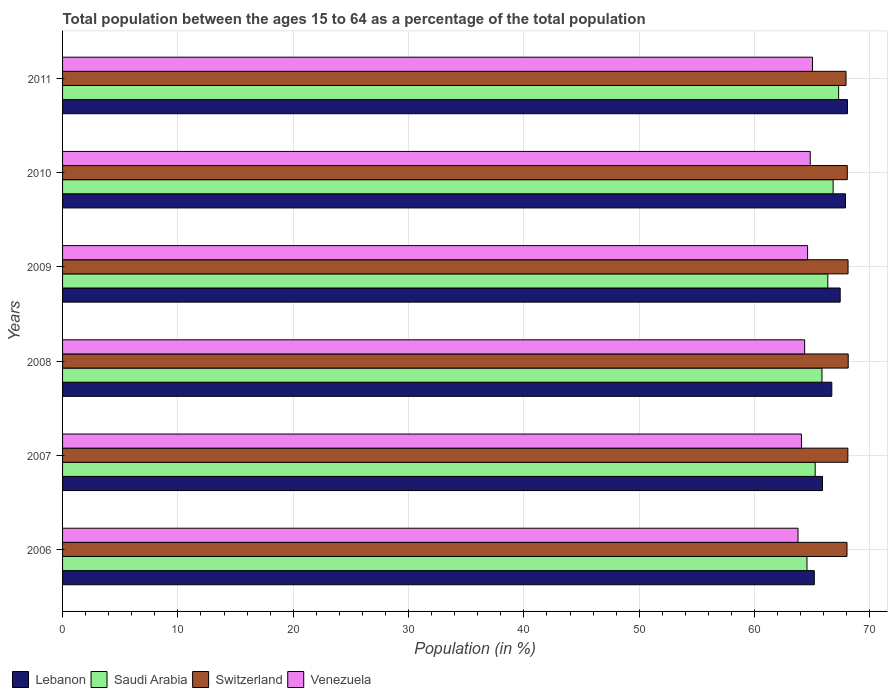How many groups of bars are there?
Keep it short and to the point. 6. How many bars are there on the 3rd tick from the bottom?
Ensure brevity in your answer.  4. In how many cases, is the number of bars for a given year not equal to the number of legend labels?
Ensure brevity in your answer.  0. What is the percentage of the population ages 15 to 64 in Lebanon in 2009?
Your answer should be very brief. 67.42. Across all years, what is the maximum percentage of the population ages 15 to 64 in Venezuela?
Your answer should be very brief. 65.02. Across all years, what is the minimum percentage of the population ages 15 to 64 in Saudi Arabia?
Your response must be concise. 64.54. What is the total percentage of the population ages 15 to 64 in Lebanon in the graph?
Ensure brevity in your answer.  401.12. What is the difference between the percentage of the population ages 15 to 64 in Lebanon in 2008 and that in 2009?
Provide a short and direct response. -0.73. What is the difference between the percentage of the population ages 15 to 64 in Lebanon in 2009 and the percentage of the population ages 15 to 64 in Saudi Arabia in 2011?
Your answer should be very brief. 0.14. What is the average percentage of the population ages 15 to 64 in Switzerland per year?
Offer a terse response. 68.05. In the year 2006, what is the difference between the percentage of the population ages 15 to 64 in Switzerland and percentage of the population ages 15 to 64 in Venezuela?
Your answer should be very brief. 4.25. In how many years, is the percentage of the population ages 15 to 64 in Saudi Arabia greater than 18 ?
Keep it short and to the point. 6. What is the ratio of the percentage of the population ages 15 to 64 in Switzerland in 2006 to that in 2010?
Offer a terse response. 1. Is the percentage of the population ages 15 to 64 in Lebanon in 2009 less than that in 2010?
Your answer should be very brief. Yes. What is the difference between the highest and the second highest percentage of the population ages 15 to 64 in Venezuela?
Keep it short and to the point. 0.2. What is the difference between the highest and the lowest percentage of the population ages 15 to 64 in Venezuela?
Make the answer very short. 1.25. In how many years, is the percentage of the population ages 15 to 64 in Venezuela greater than the average percentage of the population ages 15 to 64 in Venezuela taken over all years?
Your response must be concise. 3. Is it the case that in every year, the sum of the percentage of the population ages 15 to 64 in Switzerland and percentage of the population ages 15 to 64 in Saudi Arabia is greater than the sum of percentage of the population ages 15 to 64 in Venezuela and percentage of the population ages 15 to 64 in Lebanon?
Provide a short and direct response. Yes. What does the 2nd bar from the top in 2011 represents?
Your response must be concise. Switzerland. What does the 4th bar from the bottom in 2006 represents?
Your answer should be compact. Venezuela. Are all the bars in the graph horizontal?
Provide a succinct answer. Yes. How many years are there in the graph?
Offer a terse response. 6. Are the values on the major ticks of X-axis written in scientific E-notation?
Your answer should be compact. No. How many legend labels are there?
Offer a very short reply. 4. What is the title of the graph?
Your answer should be very brief. Total population between the ages 15 to 64 as a percentage of the total population. What is the label or title of the Y-axis?
Ensure brevity in your answer.  Years. What is the Population (in %) of Lebanon in 2006?
Keep it short and to the point. 65.18. What is the Population (in %) of Saudi Arabia in 2006?
Offer a very short reply. 64.54. What is the Population (in %) of Switzerland in 2006?
Provide a succinct answer. 68.01. What is the Population (in %) in Venezuela in 2006?
Ensure brevity in your answer.  63.77. What is the Population (in %) in Lebanon in 2007?
Provide a succinct answer. 65.89. What is the Population (in %) in Saudi Arabia in 2007?
Your answer should be very brief. 65.25. What is the Population (in %) in Switzerland in 2007?
Your answer should be very brief. 68.09. What is the Population (in %) of Venezuela in 2007?
Provide a short and direct response. 64.06. What is the Population (in %) of Lebanon in 2008?
Your response must be concise. 66.69. What is the Population (in %) of Saudi Arabia in 2008?
Ensure brevity in your answer.  65.84. What is the Population (in %) of Switzerland in 2008?
Make the answer very short. 68.12. What is the Population (in %) of Venezuela in 2008?
Offer a terse response. 64.34. What is the Population (in %) of Lebanon in 2009?
Provide a succinct answer. 67.42. What is the Population (in %) in Saudi Arabia in 2009?
Provide a succinct answer. 66.35. What is the Population (in %) in Switzerland in 2009?
Give a very brief answer. 68.1. What is the Population (in %) in Venezuela in 2009?
Give a very brief answer. 64.59. What is the Population (in %) of Lebanon in 2010?
Offer a very short reply. 67.88. What is the Population (in %) of Saudi Arabia in 2010?
Your answer should be very brief. 66.81. What is the Population (in %) of Switzerland in 2010?
Your answer should be very brief. 68.04. What is the Population (in %) of Venezuela in 2010?
Ensure brevity in your answer.  64.82. What is the Population (in %) in Lebanon in 2011?
Your answer should be very brief. 68.05. What is the Population (in %) in Saudi Arabia in 2011?
Your answer should be very brief. 67.29. What is the Population (in %) of Switzerland in 2011?
Provide a short and direct response. 67.93. What is the Population (in %) of Venezuela in 2011?
Offer a terse response. 65.02. Across all years, what is the maximum Population (in %) in Lebanon?
Ensure brevity in your answer.  68.05. Across all years, what is the maximum Population (in %) in Saudi Arabia?
Provide a short and direct response. 67.29. Across all years, what is the maximum Population (in %) of Switzerland?
Your response must be concise. 68.12. Across all years, what is the maximum Population (in %) in Venezuela?
Ensure brevity in your answer.  65.02. Across all years, what is the minimum Population (in %) in Lebanon?
Ensure brevity in your answer.  65.18. Across all years, what is the minimum Population (in %) of Saudi Arabia?
Make the answer very short. 64.54. Across all years, what is the minimum Population (in %) in Switzerland?
Offer a terse response. 67.93. Across all years, what is the minimum Population (in %) of Venezuela?
Keep it short and to the point. 63.77. What is the total Population (in %) in Lebanon in the graph?
Your answer should be very brief. 401.12. What is the total Population (in %) in Saudi Arabia in the graph?
Provide a succinct answer. 396.09. What is the total Population (in %) in Switzerland in the graph?
Your answer should be compact. 408.28. What is the total Population (in %) in Venezuela in the graph?
Offer a very short reply. 386.61. What is the difference between the Population (in %) in Lebanon in 2006 and that in 2007?
Your answer should be very brief. -0.71. What is the difference between the Population (in %) of Saudi Arabia in 2006 and that in 2007?
Give a very brief answer. -0.71. What is the difference between the Population (in %) of Switzerland in 2006 and that in 2007?
Provide a succinct answer. -0.07. What is the difference between the Population (in %) in Venezuela in 2006 and that in 2007?
Your answer should be very brief. -0.3. What is the difference between the Population (in %) of Lebanon in 2006 and that in 2008?
Provide a succinct answer. -1.52. What is the difference between the Population (in %) in Saudi Arabia in 2006 and that in 2008?
Offer a very short reply. -1.3. What is the difference between the Population (in %) in Switzerland in 2006 and that in 2008?
Keep it short and to the point. -0.1. What is the difference between the Population (in %) of Venezuela in 2006 and that in 2008?
Offer a terse response. -0.57. What is the difference between the Population (in %) of Lebanon in 2006 and that in 2009?
Offer a very short reply. -2.24. What is the difference between the Population (in %) of Saudi Arabia in 2006 and that in 2009?
Your response must be concise. -1.81. What is the difference between the Population (in %) in Switzerland in 2006 and that in 2009?
Your answer should be compact. -0.09. What is the difference between the Population (in %) of Venezuela in 2006 and that in 2009?
Your answer should be compact. -0.83. What is the difference between the Population (in %) of Lebanon in 2006 and that in 2010?
Keep it short and to the point. -2.7. What is the difference between the Population (in %) of Saudi Arabia in 2006 and that in 2010?
Offer a very short reply. -2.27. What is the difference between the Population (in %) of Switzerland in 2006 and that in 2010?
Provide a succinct answer. -0.03. What is the difference between the Population (in %) of Venezuela in 2006 and that in 2010?
Make the answer very short. -1.06. What is the difference between the Population (in %) in Lebanon in 2006 and that in 2011?
Ensure brevity in your answer.  -2.87. What is the difference between the Population (in %) in Saudi Arabia in 2006 and that in 2011?
Offer a very short reply. -2.74. What is the difference between the Population (in %) of Switzerland in 2006 and that in 2011?
Offer a very short reply. 0.08. What is the difference between the Population (in %) of Venezuela in 2006 and that in 2011?
Ensure brevity in your answer.  -1.25. What is the difference between the Population (in %) of Lebanon in 2007 and that in 2008?
Offer a very short reply. -0.81. What is the difference between the Population (in %) of Saudi Arabia in 2007 and that in 2008?
Your answer should be very brief. -0.59. What is the difference between the Population (in %) in Switzerland in 2007 and that in 2008?
Provide a succinct answer. -0.03. What is the difference between the Population (in %) in Venezuela in 2007 and that in 2008?
Your answer should be compact. -0.28. What is the difference between the Population (in %) of Lebanon in 2007 and that in 2009?
Your answer should be compact. -1.53. What is the difference between the Population (in %) of Saudi Arabia in 2007 and that in 2009?
Provide a short and direct response. -1.1. What is the difference between the Population (in %) of Switzerland in 2007 and that in 2009?
Offer a terse response. -0.02. What is the difference between the Population (in %) in Venezuela in 2007 and that in 2009?
Provide a short and direct response. -0.53. What is the difference between the Population (in %) in Lebanon in 2007 and that in 2010?
Keep it short and to the point. -1.99. What is the difference between the Population (in %) of Saudi Arabia in 2007 and that in 2010?
Keep it short and to the point. -1.56. What is the difference between the Population (in %) of Switzerland in 2007 and that in 2010?
Provide a short and direct response. 0.05. What is the difference between the Population (in %) of Venezuela in 2007 and that in 2010?
Provide a succinct answer. -0.76. What is the difference between the Population (in %) in Lebanon in 2007 and that in 2011?
Your answer should be very brief. -2.16. What is the difference between the Population (in %) of Saudi Arabia in 2007 and that in 2011?
Your answer should be compact. -2.03. What is the difference between the Population (in %) of Switzerland in 2007 and that in 2011?
Your response must be concise. 0.16. What is the difference between the Population (in %) in Venezuela in 2007 and that in 2011?
Make the answer very short. -0.96. What is the difference between the Population (in %) of Lebanon in 2008 and that in 2009?
Offer a very short reply. -0.73. What is the difference between the Population (in %) in Saudi Arabia in 2008 and that in 2009?
Your answer should be compact. -0.51. What is the difference between the Population (in %) in Switzerland in 2008 and that in 2009?
Your response must be concise. 0.01. What is the difference between the Population (in %) in Venezuela in 2008 and that in 2009?
Offer a very short reply. -0.25. What is the difference between the Population (in %) of Lebanon in 2008 and that in 2010?
Make the answer very short. -1.19. What is the difference between the Population (in %) in Saudi Arabia in 2008 and that in 2010?
Offer a very short reply. -0.97. What is the difference between the Population (in %) of Switzerland in 2008 and that in 2010?
Your response must be concise. 0.08. What is the difference between the Population (in %) in Venezuela in 2008 and that in 2010?
Your response must be concise. -0.48. What is the difference between the Population (in %) in Lebanon in 2008 and that in 2011?
Provide a short and direct response. -1.36. What is the difference between the Population (in %) in Saudi Arabia in 2008 and that in 2011?
Your answer should be compact. -1.44. What is the difference between the Population (in %) of Switzerland in 2008 and that in 2011?
Make the answer very short. 0.19. What is the difference between the Population (in %) of Venezuela in 2008 and that in 2011?
Give a very brief answer. -0.68. What is the difference between the Population (in %) of Lebanon in 2009 and that in 2010?
Make the answer very short. -0.46. What is the difference between the Population (in %) of Saudi Arabia in 2009 and that in 2010?
Make the answer very short. -0.46. What is the difference between the Population (in %) in Switzerland in 2009 and that in 2010?
Offer a terse response. 0.06. What is the difference between the Population (in %) in Venezuela in 2009 and that in 2010?
Your answer should be very brief. -0.23. What is the difference between the Population (in %) in Lebanon in 2009 and that in 2011?
Offer a terse response. -0.63. What is the difference between the Population (in %) in Saudi Arabia in 2009 and that in 2011?
Provide a short and direct response. -0.94. What is the difference between the Population (in %) in Switzerland in 2009 and that in 2011?
Your answer should be compact. 0.17. What is the difference between the Population (in %) in Venezuela in 2009 and that in 2011?
Ensure brevity in your answer.  -0.43. What is the difference between the Population (in %) of Lebanon in 2010 and that in 2011?
Your response must be concise. -0.17. What is the difference between the Population (in %) of Saudi Arabia in 2010 and that in 2011?
Provide a succinct answer. -0.47. What is the difference between the Population (in %) of Switzerland in 2010 and that in 2011?
Make the answer very short. 0.11. What is the difference between the Population (in %) in Venezuela in 2010 and that in 2011?
Offer a terse response. -0.2. What is the difference between the Population (in %) of Lebanon in 2006 and the Population (in %) of Saudi Arabia in 2007?
Offer a very short reply. -0.08. What is the difference between the Population (in %) of Lebanon in 2006 and the Population (in %) of Switzerland in 2007?
Your answer should be compact. -2.91. What is the difference between the Population (in %) of Lebanon in 2006 and the Population (in %) of Venezuela in 2007?
Give a very brief answer. 1.11. What is the difference between the Population (in %) of Saudi Arabia in 2006 and the Population (in %) of Switzerland in 2007?
Your answer should be very brief. -3.54. What is the difference between the Population (in %) in Saudi Arabia in 2006 and the Population (in %) in Venezuela in 2007?
Provide a succinct answer. 0.48. What is the difference between the Population (in %) in Switzerland in 2006 and the Population (in %) in Venezuela in 2007?
Your response must be concise. 3.95. What is the difference between the Population (in %) in Lebanon in 2006 and the Population (in %) in Saudi Arabia in 2008?
Ensure brevity in your answer.  -0.66. What is the difference between the Population (in %) of Lebanon in 2006 and the Population (in %) of Switzerland in 2008?
Provide a short and direct response. -2.94. What is the difference between the Population (in %) in Lebanon in 2006 and the Population (in %) in Venezuela in 2008?
Keep it short and to the point. 0.84. What is the difference between the Population (in %) of Saudi Arabia in 2006 and the Population (in %) of Switzerland in 2008?
Your answer should be very brief. -3.57. What is the difference between the Population (in %) in Saudi Arabia in 2006 and the Population (in %) in Venezuela in 2008?
Your response must be concise. 0.2. What is the difference between the Population (in %) of Switzerland in 2006 and the Population (in %) of Venezuela in 2008?
Your answer should be very brief. 3.67. What is the difference between the Population (in %) in Lebanon in 2006 and the Population (in %) in Saudi Arabia in 2009?
Offer a terse response. -1.17. What is the difference between the Population (in %) of Lebanon in 2006 and the Population (in %) of Switzerland in 2009?
Keep it short and to the point. -2.92. What is the difference between the Population (in %) of Lebanon in 2006 and the Population (in %) of Venezuela in 2009?
Give a very brief answer. 0.58. What is the difference between the Population (in %) in Saudi Arabia in 2006 and the Population (in %) in Switzerland in 2009?
Provide a short and direct response. -3.56. What is the difference between the Population (in %) of Saudi Arabia in 2006 and the Population (in %) of Venezuela in 2009?
Make the answer very short. -0.05. What is the difference between the Population (in %) of Switzerland in 2006 and the Population (in %) of Venezuela in 2009?
Your response must be concise. 3.42. What is the difference between the Population (in %) of Lebanon in 2006 and the Population (in %) of Saudi Arabia in 2010?
Your answer should be very brief. -1.63. What is the difference between the Population (in %) of Lebanon in 2006 and the Population (in %) of Switzerland in 2010?
Keep it short and to the point. -2.86. What is the difference between the Population (in %) in Lebanon in 2006 and the Population (in %) in Venezuela in 2010?
Provide a succinct answer. 0.35. What is the difference between the Population (in %) of Saudi Arabia in 2006 and the Population (in %) of Switzerland in 2010?
Give a very brief answer. -3.49. What is the difference between the Population (in %) in Saudi Arabia in 2006 and the Population (in %) in Venezuela in 2010?
Your answer should be very brief. -0.28. What is the difference between the Population (in %) in Switzerland in 2006 and the Population (in %) in Venezuela in 2010?
Your answer should be very brief. 3.19. What is the difference between the Population (in %) in Lebanon in 2006 and the Population (in %) in Saudi Arabia in 2011?
Offer a terse response. -2.11. What is the difference between the Population (in %) of Lebanon in 2006 and the Population (in %) of Switzerland in 2011?
Offer a very short reply. -2.75. What is the difference between the Population (in %) in Lebanon in 2006 and the Population (in %) in Venezuela in 2011?
Give a very brief answer. 0.16. What is the difference between the Population (in %) of Saudi Arabia in 2006 and the Population (in %) of Switzerland in 2011?
Give a very brief answer. -3.39. What is the difference between the Population (in %) in Saudi Arabia in 2006 and the Population (in %) in Venezuela in 2011?
Your response must be concise. -0.48. What is the difference between the Population (in %) in Switzerland in 2006 and the Population (in %) in Venezuela in 2011?
Provide a short and direct response. 2.99. What is the difference between the Population (in %) in Lebanon in 2007 and the Population (in %) in Saudi Arabia in 2008?
Your response must be concise. 0.05. What is the difference between the Population (in %) of Lebanon in 2007 and the Population (in %) of Switzerland in 2008?
Offer a terse response. -2.23. What is the difference between the Population (in %) of Lebanon in 2007 and the Population (in %) of Venezuela in 2008?
Provide a short and direct response. 1.55. What is the difference between the Population (in %) in Saudi Arabia in 2007 and the Population (in %) in Switzerland in 2008?
Ensure brevity in your answer.  -2.86. What is the difference between the Population (in %) of Saudi Arabia in 2007 and the Population (in %) of Venezuela in 2008?
Your answer should be very brief. 0.91. What is the difference between the Population (in %) in Switzerland in 2007 and the Population (in %) in Venezuela in 2008?
Offer a terse response. 3.75. What is the difference between the Population (in %) of Lebanon in 2007 and the Population (in %) of Saudi Arabia in 2009?
Keep it short and to the point. -0.46. What is the difference between the Population (in %) in Lebanon in 2007 and the Population (in %) in Switzerland in 2009?
Keep it short and to the point. -2.21. What is the difference between the Population (in %) of Lebanon in 2007 and the Population (in %) of Venezuela in 2009?
Make the answer very short. 1.29. What is the difference between the Population (in %) in Saudi Arabia in 2007 and the Population (in %) in Switzerland in 2009?
Your answer should be compact. -2.85. What is the difference between the Population (in %) of Saudi Arabia in 2007 and the Population (in %) of Venezuela in 2009?
Keep it short and to the point. 0.66. What is the difference between the Population (in %) in Switzerland in 2007 and the Population (in %) in Venezuela in 2009?
Give a very brief answer. 3.49. What is the difference between the Population (in %) of Lebanon in 2007 and the Population (in %) of Saudi Arabia in 2010?
Offer a very short reply. -0.92. What is the difference between the Population (in %) of Lebanon in 2007 and the Population (in %) of Switzerland in 2010?
Keep it short and to the point. -2.15. What is the difference between the Population (in %) in Lebanon in 2007 and the Population (in %) in Venezuela in 2010?
Provide a short and direct response. 1.06. What is the difference between the Population (in %) of Saudi Arabia in 2007 and the Population (in %) of Switzerland in 2010?
Provide a succinct answer. -2.78. What is the difference between the Population (in %) of Saudi Arabia in 2007 and the Population (in %) of Venezuela in 2010?
Your answer should be compact. 0.43. What is the difference between the Population (in %) of Switzerland in 2007 and the Population (in %) of Venezuela in 2010?
Your answer should be compact. 3.26. What is the difference between the Population (in %) of Lebanon in 2007 and the Population (in %) of Saudi Arabia in 2011?
Offer a terse response. -1.4. What is the difference between the Population (in %) of Lebanon in 2007 and the Population (in %) of Switzerland in 2011?
Offer a very short reply. -2.04. What is the difference between the Population (in %) in Lebanon in 2007 and the Population (in %) in Venezuela in 2011?
Your response must be concise. 0.87. What is the difference between the Population (in %) of Saudi Arabia in 2007 and the Population (in %) of Switzerland in 2011?
Ensure brevity in your answer.  -2.67. What is the difference between the Population (in %) of Saudi Arabia in 2007 and the Population (in %) of Venezuela in 2011?
Your answer should be very brief. 0.23. What is the difference between the Population (in %) of Switzerland in 2007 and the Population (in %) of Venezuela in 2011?
Offer a terse response. 3.07. What is the difference between the Population (in %) of Lebanon in 2008 and the Population (in %) of Saudi Arabia in 2009?
Your answer should be compact. 0.34. What is the difference between the Population (in %) in Lebanon in 2008 and the Population (in %) in Switzerland in 2009?
Your answer should be compact. -1.41. What is the difference between the Population (in %) in Lebanon in 2008 and the Population (in %) in Venezuela in 2009?
Provide a succinct answer. 2.1. What is the difference between the Population (in %) in Saudi Arabia in 2008 and the Population (in %) in Switzerland in 2009?
Offer a very short reply. -2.26. What is the difference between the Population (in %) of Saudi Arabia in 2008 and the Population (in %) of Venezuela in 2009?
Your answer should be compact. 1.25. What is the difference between the Population (in %) in Switzerland in 2008 and the Population (in %) in Venezuela in 2009?
Your answer should be very brief. 3.52. What is the difference between the Population (in %) in Lebanon in 2008 and the Population (in %) in Saudi Arabia in 2010?
Offer a very short reply. -0.12. What is the difference between the Population (in %) of Lebanon in 2008 and the Population (in %) of Switzerland in 2010?
Provide a short and direct response. -1.34. What is the difference between the Population (in %) in Lebanon in 2008 and the Population (in %) in Venezuela in 2010?
Provide a succinct answer. 1.87. What is the difference between the Population (in %) in Saudi Arabia in 2008 and the Population (in %) in Switzerland in 2010?
Keep it short and to the point. -2.2. What is the difference between the Population (in %) in Saudi Arabia in 2008 and the Population (in %) in Venezuela in 2010?
Ensure brevity in your answer.  1.02. What is the difference between the Population (in %) of Switzerland in 2008 and the Population (in %) of Venezuela in 2010?
Keep it short and to the point. 3.29. What is the difference between the Population (in %) of Lebanon in 2008 and the Population (in %) of Saudi Arabia in 2011?
Offer a very short reply. -0.59. What is the difference between the Population (in %) in Lebanon in 2008 and the Population (in %) in Switzerland in 2011?
Your answer should be compact. -1.23. What is the difference between the Population (in %) of Lebanon in 2008 and the Population (in %) of Venezuela in 2011?
Keep it short and to the point. 1.67. What is the difference between the Population (in %) of Saudi Arabia in 2008 and the Population (in %) of Switzerland in 2011?
Your response must be concise. -2.09. What is the difference between the Population (in %) of Saudi Arabia in 2008 and the Population (in %) of Venezuela in 2011?
Provide a short and direct response. 0.82. What is the difference between the Population (in %) in Switzerland in 2008 and the Population (in %) in Venezuela in 2011?
Ensure brevity in your answer.  3.1. What is the difference between the Population (in %) of Lebanon in 2009 and the Population (in %) of Saudi Arabia in 2010?
Your answer should be compact. 0.61. What is the difference between the Population (in %) in Lebanon in 2009 and the Population (in %) in Switzerland in 2010?
Provide a short and direct response. -0.62. What is the difference between the Population (in %) of Lebanon in 2009 and the Population (in %) of Venezuela in 2010?
Offer a terse response. 2.6. What is the difference between the Population (in %) in Saudi Arabia in 2009 and the Population (in %) in Switzerland in 2010?
Your answer should be very brief. -1.69. What is the difference between the Population (in %) of Saudi Arabia in 2009 and the Population (in %) of Venezuela in 2010?
Ensure brevity in your answer.  1.53. What is the difference between the Population (in %) of Switzerland in 2009 and the Population (in %) of Venezuela in 2010?
Your response must be concise. 3.28. What is the difference between the Population (in %) of Lebanon in 2009 and the Population (in %) of Saudi Arabia in 2011?
Ensure brevity in your answer.  0.14. What is the difference between the Population (in %) of Lebanon in 2009 and the Population (in %) of Switzerland in 2011?
Provide a short and direct response. -0.51. What is the difference between the Population (in %) of Lebanon in 2009 and the Population (in %) of Venezuela in 2011?
Provide a short and direct response. 2.4. What is the difference between the Population (in %) in Saudi Arabia in 2009 and the Population (in %) in Switzerland in 2011?
Keep it short and to the point. -1.58. What is the difference between the Population (in %) of Saudi Arabia in 2009 and the Population (in %) of Venezuela in 2011?
Give a very brief answer. 1.33. What is the difference between the Population (in %) of Switzerland in 2009 and the Population (in %) of Venezuela in 2011?
Your answer should be compact. 3.08. What is the difference between the Population (in %) in Lebanon in 2010 and the Population (in %) in Saudi Arabia in 2011?
Ensure brevity in your answer.  0.6. What is the difference between the Population (in %) of Lebanon in 2010 and the Population (in %) of Switzerland in 2011?
Offer a terse response. -0.05. What is the difference between the Population (in %) of Lebanon in 2010 and the Population (in %) of Venezuela in 2011?
Make the answer very short. 2.86. What is the difference between the Population (in %) in Saudi Arabia in 2010 and the Population (in %) in Switzerland in 2011?
Offer a terse response. -1.12. What is the difference between the Population (in %) of Saudi Arabia in 2010 and the Population (in %) of Venezuela in 2011?
Your response must be concise. 1.79. What is the difference between the Population (in %) in Switzerland in 2010 and the Population (in %) in Venezuela in 2011?
Provide a short and direct response. 3.02. What is the average Population (in %) in Lebanon per year?
Your response must be concise. 66.85. What is the average Population (in %) of Saudi Arabia per year?
Provide a succinct answer. 66.01. What is the average Population (in %) in Switzerland per year?
Keep it short and to the point. 68.05. What is the average Population (in %) in Venezuela per year?
Your response must be concise. 64.43. In the year 2006, what is the difference between the Population (in %) in Lebanon and Population (in %) in Saudi Arabia?
Provide a succinct answer. 0.64. In the year 2006, what is the difference between the Population (in %) in Lebanon and Population (in %) in Switzerland?
Keep it short and to the point. -2.83. In the year 2006, what is the difference between the Population (in %) in Lebanon and Population (in %) in Venezuela?
Ensure brevity in your answer.  1.41. In the year 2006, what is the difference between the Population (in %) in Saudi Arabia and Population (in %) in Switzerland?
Your response must be concise. -3.47. In the year 2006, what is the difference between the Population (in %) in Saudi Arabia and Population (in %) in Venezuela?
Your answer should be very brief. 0.78. In the year 2006, what is the difference between the Population (in %) of Switzerland and Population (in %) of Venezuela?
Make the answer very short. 4.25. In the year 2007, what is the difference between the Population (in %) in Lebanon and Population (in %) in Saudi Arabia?
Provide a short and direct response. 0.63. In the year 2007, what is the difference between the Population (in %) of Lebanon and Population (in %) of Switzerland?
Provide a succinct answer. -2.2. In the year 2007, what is the difference between the Population (in %) in Lebanon and Population (in %) in Venezuela?
Your response must be concise. 1.82. In the year 2007, what is the difference between the Population (in %) of Saudi Arabia and Population (in %) of Switzerland?
Offer a very short reply. -2.83. In the year 2007, what is the difference between the Population (in %) of Saudi Arabia and Population (in %) of Venezuela?
Keep it short and to the point. 1.19. In the year 2007, what is the difference between the Population (in %) of Switzerland and Population (in %) of Venezuela?
Offer a very short reply. 4.02. In the year 2008, what is the difference between the Population (in %) of Lebanon and Population (in %) of Saudi Arabia?
Offer a very short reply. 0.85. In the year 2008, what is the difference between the Population (in %) in Lebanon and Population (in %) in Switzerland?
Give a very brief answer. -1.42. In the year 2008, what is the difference between the Population (in %) in Lebanon and Population (in %) in Venezuela?
Ensure brevity in your answer.  2.35. In the year 2008, what is the difference between the Population (in %) of Saudi Arabia and Population (in %) of Switzerland?
Your response must be concise. -2.27. In the year 2008, what is the difference between the Population (in %) of Saudi Arabia and Population (in %) of Venezuela?
Ensure brevity in your answer.  1.5. In the year 2008, what is the difference between the Population (in %) of Switzerland and Population (in %) of Venezuela?
Ensure brevity in your answer.  3.78. In the year 2009, what is the difference between the Population (in %) in Lebanon and Population (in %) in Saudi Arabia?
Offer a terse response. 1.07. In the year 2009, what is the difference between the Population (in %) of Lebanon and Population (in %) of Switzerland?
Make the answer very short. -0.68. In the year 2009, what is the difference between the Population (in %) of Lebanon and Population (in %) of Venezuela?
Give a very brief answer. 2.83. In the year 2009, what is the difference between the Population (in %) in Saudi Arabia and Population (in %) in Switzerland?
Give a very brief answer. -1.75. In the year 2009, what is the difference between the Population (in %) in Saudi Arabia and Population (in %) in Venezuela?
Offer a very short reply. 1.76. In the year 2009, what is the difference between the Population (in %) of Switzerland and Population (in %) of Venezuela?
Offer a terse response. 3.51. In the year 2010, what is the difference between the Population (in %) of Lebanon and Population (in %) of Saudi Arabia?
Your answer should be very brief. 1.07. In the year 2010, what is the difference between the Population (in %) of Lebanon and Population (in %) of Switzerland?
Your answer should be compact. -0.16. In the year 2010, what is the difference between the Population (in %) of Lebanon and Population (in %) of Venezuela?
Offer a very short reply. 3.06. In the year 2010, what is the difference between the Population (in %) in Saudi Arabia and Population (in %) in Switzerland?
Offer a very short reply. -1.23. In the year 2010, what is the difference between the Population (in %) of Saudi Arabia and Population (in %) of Venezuela?
Your answer should be very brief. 1.99. In the year 2010, what is the difference between the Population (in %) of Switzerland and Population (in %) of Venezuela?
Keep it short and to the point. 3.21. In the year 2011, what is the difference between the Population (in %) of Lebanon and Population (in %) of Saudi Arabia?
Offer a terse response. 0.77. In the year 2011, what is the difference between the Population (in %) in Lebanon and Population (in %) in Switzerland?
Make the answer very short. 0.12. In the year 2011, what is the difference between the Population (in %) in Lebanon and Population (in %) in Venezuela?
Provide a short and direct response. 3.03. In the year 2011, what is the difference between the Population (in %) of Saudi Arabia and Population (in %) of Switzerland?
Offer a terse response. -0.64. In the year 2011, what is the difference between the Population (in %) in Saudi Arabia and Population (in %) in Venezuela?
Keep it short and to the point. 2.27. In the year 2011, what is the difference between the Population (in %) of Switzerland and Population (in %) of Venezuela?
Your answer should be compact. 2.91. What is the ratio of the Population (in %) in Saudi Arabia in 2006 to that in 2007?
Provide a succinct answer. 0.99. What is the ratio of the Population (in %) in Venezuela in 2006 to that in 2007?
Provide a short and direct response. 1. What is the ratio of the Population (in %) of Lebanon in 2006 to that in 2008?
Your response must be concise. 0.98. What is the ratio of the Population (in %) of Saudi Arabia in 2006 to that in 2008?
Your response must be concise. 0.98. What is the ratio of the Population (in %) in Switzerland in 2006 to that in 2008?
Your response must be concise. 1. What is the ratio of the Population (in %) of Lebanon in 2006 to that in 2009?
Offer a terse response. 0.97. What is the ratio of the Population (in %) in Saudi Arabia in 2006 to that in 2009?
Offer a terse response. 0.97. What is the ratio of the Population (in %) in Switzerland in 2006 to that in 2009?
Provide a short and direct response. 1. What is the ratio of the Population (in %) in Venezuela in 2006 to that in 2009?
Keep it short and to the point. 0.99. What is the ratio of the Population (in %) in Lebanon in 2006 to that in 2010?
Provide a succinct answer. 0.96. What is the ratio of the Population (in %) of Saudi Arabia in 2006 to that in 2010?
Provide a short and direct response. 0.97. What is the ratio of the Population (in %) in Switzerland in 2006 to that in 2010?
Your answer should be very brief. 1. What is the ratio of the Population (in %) in Venezuela in 2006 to that in 2010?
Keep it short and to the point. 0.98. What is the ratio of the Population (in %) in Lebanon in 2006 to that in 2011?
Make the answer very short. 0.96. What is the ratio of the Population (in %) of Saudi Arabia in 2006 to that in 2011?
Provide a succinct answer. 0.96. What is the ratio of the Population (in %) of Venezuela in 2006 to that in 2011?
Your response must be concise. 0.98. What is the ratio of the Population (in %) in Lebanon in 2007 to that in 2008?
Your answer should be compact. 0.99. What is the ratio of the Population (in %) of Venezuela in 2007 to that in 2008?
Offer a very short reply. 1. What is the ratio of the Population (in %) of Lebanon in 2007 to that in 2009?
Make the answer very short. 0.98. What is the ratio of the Population (in %) in Saudi Arabia in 2007 to that in 2009?
Make the answer very short. 0.98. What is the ratio of the Population (in %) in Switzerland in 2007 to that in 2009?
Provide a short and direct response. 1. What is the ratio of the Population (in %) of Venezuela in 2007 to that in 2009?
Make the answer very short. 0.99. What is the ratio of the Population (in %) in Lebanon in 2007 to that in 2010?
Provide a succinct answer. 0.97. What is the ratio of the Population (in %) of Saudi Arabia in 2007 to that in 2010?
Keep it short and to the point. 0.98. What is the ratio of the Population (in %) in Switzerland in 2007 to that in 2010?
Your answer should be very brief. 1. What is the ratio of the Population (in %) of Venezuela in 2007 to that in 2010?
Make the answer very short. 0.99. What is the ratio of the Population (in %) of Lebanon in 2007 to that in 2011?
Your answer should be very brief. 0.97. What is the ratio of the Population (in %) in Saudi Arabia in 2007 to that in 2011?
Offer a terse response. 0.97. What is the ratio of the Population (in %) in Switzerland in 2007 to that in 2011?
Provide a short and direct response. 1. What is the ratio of the Population (in %) in Lebanon in 2008 to that in 2009?
Keep it short and to the point. 0.99. What is the ratio of the Population (in %) of Switzerland in 2008 to that in 2009?
Provide a succinct answer. 1. What is the ratio of the Population (in %) of Venezuela in 2008 to that in 2009?
Your response must be concise. 1. What is the ratio of the Population (in %) of Lebanon in 2008 to that in 2010?
Your answer should be very brief. 0.98. What is the ratio of the Population (in %) in Saudi Arabia in 2008 to that in 2010?
Provide a succinct answer. 0.99. What is the ratio of the Population (in %) of Lebanon in 2008 to that in 2011?
Your response must be concise. 0.98. What is the ratio of the Population (in %) of Saudi Arabia in 2008 to that in 2011?
Make the answer very short. 0.98. What is the ratio of the Population (in %) of Switzerland in 2008 to that in 2011?
Your response must be concise. 1. What is the ratio of the Population (in %) of Venezuela in 2008 to that in 2011?
Your response must be concise. 0.99. What is the ratio of the Population (in %) in Lebanon in 2009 to that in 2010?
Offer a very short reply. 0.99. What is the ratio of the Population (in %) of Saudi Arabia in 2009 to that in 2010?
Ensure brevity in your answer.  0.99. What is the ratio of the Population (in %) of Switzerland in 2009 to that in 2010?
Keep it short and to the point. 1. What is the ratio of the Population (in %) of Saudi Arabia in 2009 to that in 2011?
Keep it short and to the point. 0.99. What is the ratio of the Population (in %) of Switzerland in 2009 to that in 2011?
Offer a very short reply. 1. What is the ratio of the Population (in %) in Lebanon in 2010 to that in 2011?
Give a very brief answer. 1. What is the difference between the highest and the second highest Population (in %) of Lebanon?
Keep it short and to the point. 0.17. What is the difference between the highest and the second highest Population (in %) of Saudi Arabia?
Provide a short and direct response. 0.47. What is the difference between the highest and the second highest Population (in %) in Switzerland?
Keep it short and to the point. 0.01. What is the difference between the highest and the second highest Population (in %) of Venezuela?
Make the answer very short. 0.2. What is the difference between the highest and the lowest Population (in %) of Lebanon?
Provide a succinct answer. 2.87. What is the difference between the highest and the lowest Population (in %) of Saudi Arabia?
Your answer should be compact. 2.74. What is the difference between the highest and the lowest Population (in %) in Switzerland?
Provide a short and direct response. 0.19. What is the difference between the highest and the lowest Population (in %) of Venezuela?
Offer a very short reply. 1.25. 